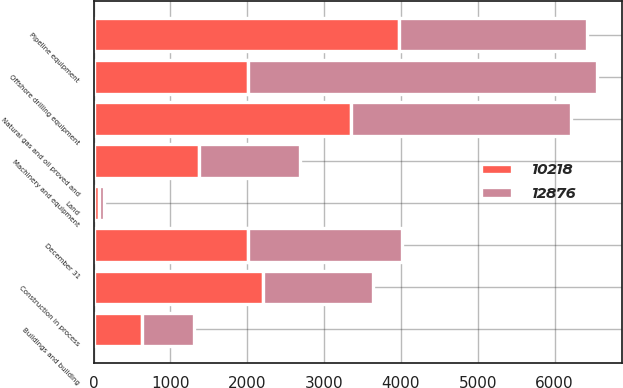<chart> <loc_0><loc_0><loc_500><loc_500><stacked_bar_chart><ecel><fcel>December 31<fcel>Land<fcel>Buildings and building<fcel>Offshore drilling equipment<fcel>Machinery and equipment<fcel>Pipeline equipment<fcel>Natural gas and oil proved and<fcel>Construction in process<nl><fcel>10218<fcel>2008<fcel>70<fcel>635<fcel>2007<fcel>1375<fcel>3978<fcel>3345<fcel>2210<nl><fcel>12876<fcel>2007<fcel>70<fcel>670<fcel>4540<fcel>1313<fcel>2445<fcel>2869<fcel>1423<nl></chart> 